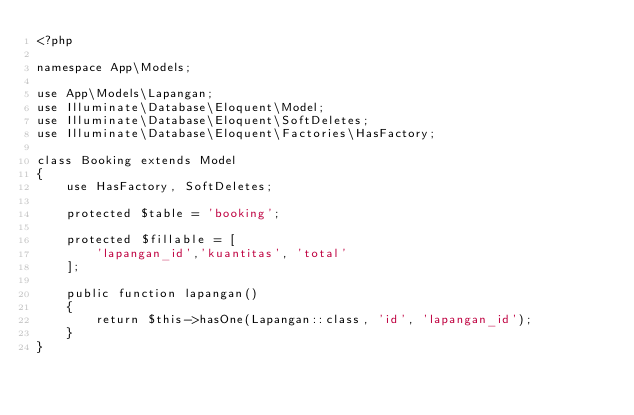<code> <loc_0><loc_0><loc_500><loc_500><_PHP_><?php

namespace App\Models;

use App\Models\Lapangan;
use Illuminate\Database\Eloquent\Model;
use Illuminate\Database\Eloquent\SoftDeletes;
use Illuminate\Database\Eloquent\Factories\HasFactory;

class Booking extends Model
{
    use HasFactory, SoftDeletes;

    protected $table = 'booking';

    protected $fillable = [
        'lapangan_id','kuantitas', 'total'
    ];

    public function lapangan()
    {
        return $this->hasOne(Lapangan::class, 'id', 'lapangan_id');
    }
}
</code> 